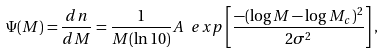Convert formula to latex. <formula><loc_0><loc_0><loc_500><loc_500>\Psi ( M ) = \frac { d n } { d M } = \frac { 1 } { M ( \ln 1 0 ) } A \ e x p \left [ \frac { - ( \log M - \log M _ { c } ) ^ { 2 } } { 2 \sigma ^ { 2 } } \right ] ,</formula> 